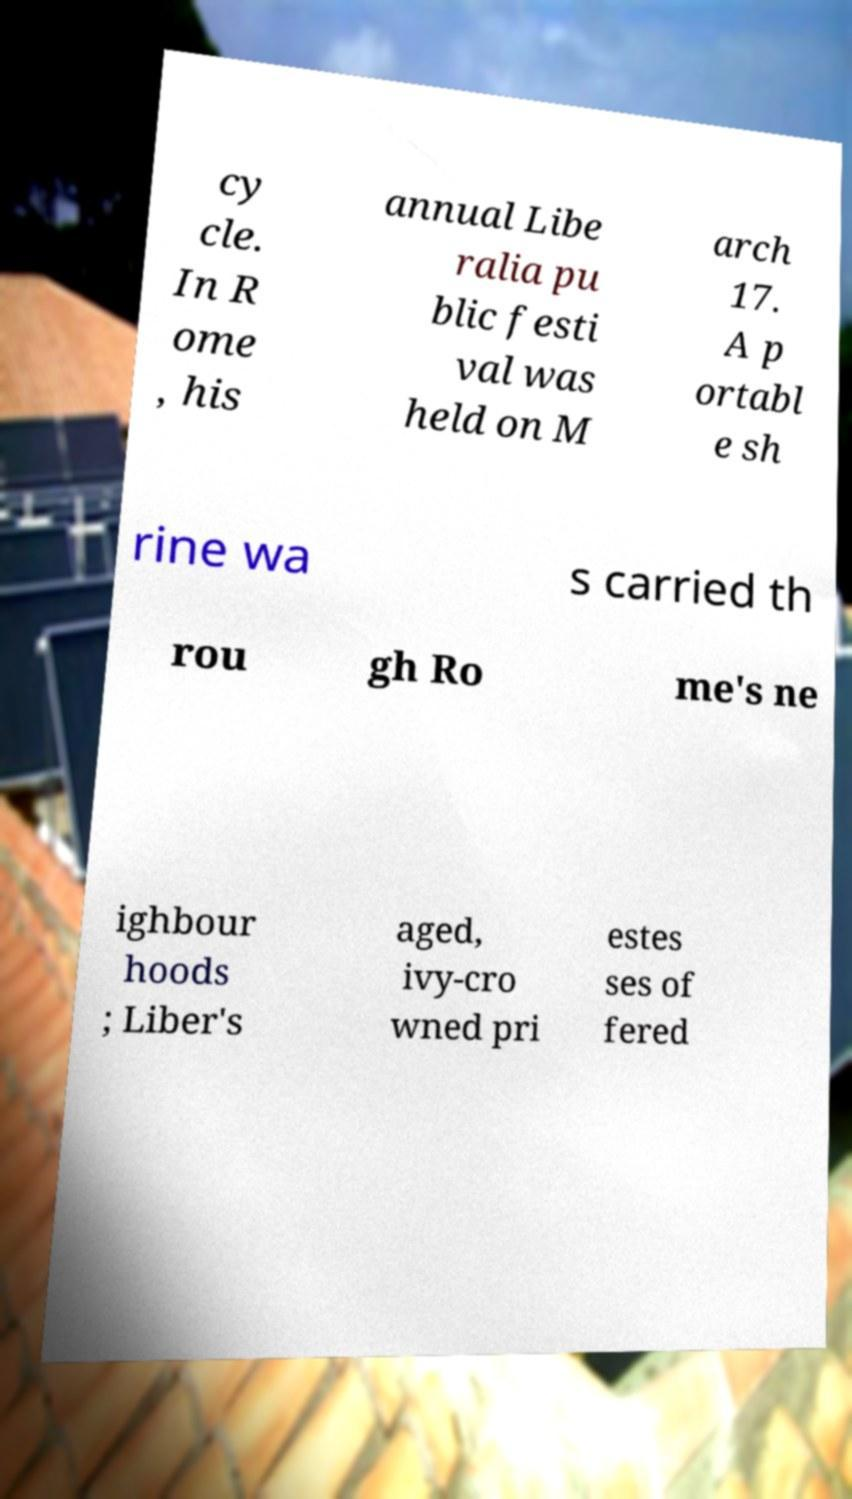Could you extract and type out the text from this image? cy cle. In R ome , his annual Libe ralia pu blic festi val was held on M arch 17. A p ortabl e sh rine wa s carried th rou gh Ro me's ne ighbour hoods ; Liber's aged, ivy-cro wned pri estes ses of fered 